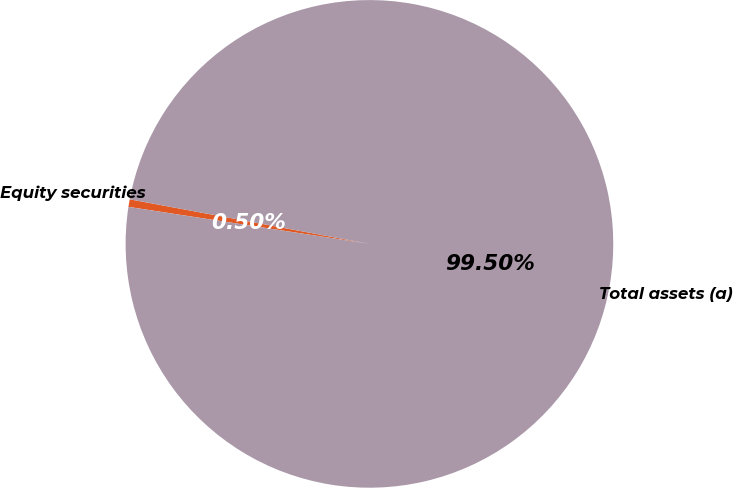<chart> <loc_0><loc_0><loc_500><loc_500><pie_chart><fcel>Equity securities<fcel>Total assets (a)<nl><fcel>0.5%<fcel>99.5%<nl></chart> 